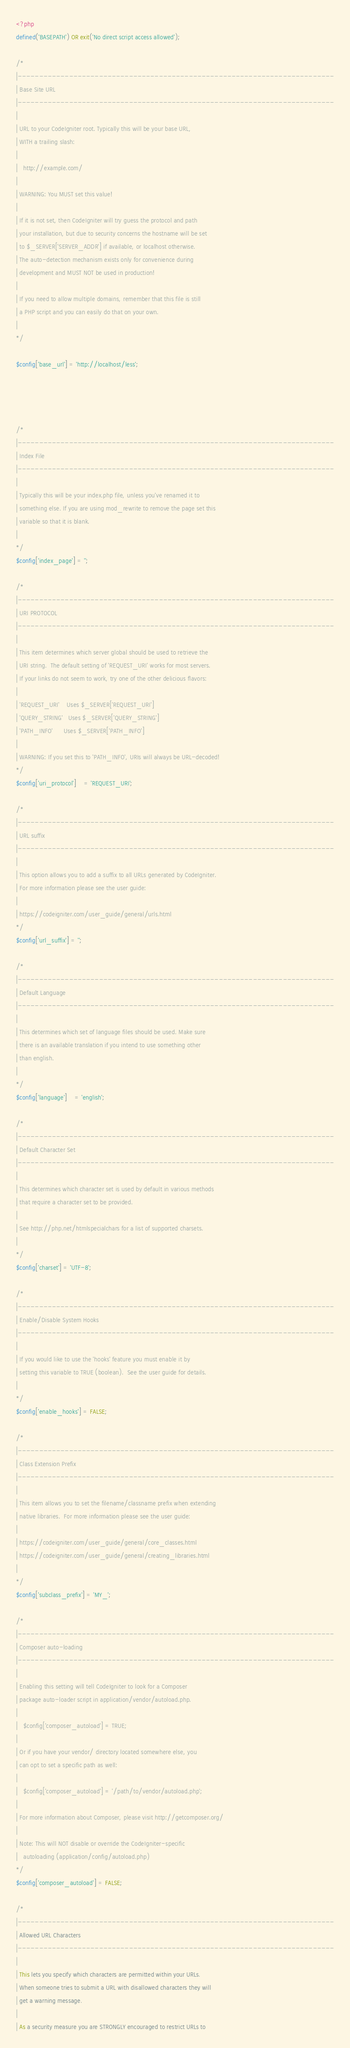Convert code to text. <code><loc_0><loc_0><loc_500><loc_500><_PHP_><?php
defined('BASEPATH') OR exit('No direct script access allowed');

/*
|--------------------------------------------------------------------------
| Base Site URL
|--------------------------------------------------------------------------
|
| URL to your CodeIgniter root. Typically this will be your base URL,
| WITH a trailing slash:
|
|	http://example.com/
|
| WARNING: You MUST set this value!
|
| If it is not set, then CodeIgniter will try guess the protocol and path
| your installation, but due to security concerns the hostname will be set
| to $_SERVER['SERVER_ADDR'] if available, or localhost otherwise.
| The auto-detection mechanism exists only for convenience during
| development and MUST NOT be used in production!
|
| If you need to allow multiple domains, remember that this file is still
| a PHP script and you can easily do that on your own.
|
*/

$config['base_url'] = 'http://localhost/less';




/*
|--------------------------------------------------------------------------
| Index File
|--------------------------------------------------------------------------
|
| Typically this will be your index.php file, unless you've renamed it to
| something else. If you are using mod_rewrite to remove the page set this
| variable so that it is blank.
|
*/
$config['index_page'] = '';

/*
|--------------------------------------------------------------------------
| URI PROTOCOL
|--------------------------------------------------------------------------
|
| This item determines which server global should be used to retrieve the
| URI string.  The default setting of 'REQUEST_URI' works for most servers.
| If your links do not seem to work, try one of the other delicious flavors:
|
| 'REQUEST_URI'    Uses $_SERVER['REQUEST_URI']
| 'QUERY_STRING'   Uses $_SERVER['QUERY_STRING']
| 'PATH_INFO'      Uses $_SERVER['PATH_INFO']
|
| WARNING: If you set this to 'PATH_INFO', URIs will always be URL-decoded!
*/
$config['uri_protocol']	= 'REQUEST_URI';

/*
|--------------------------------------------------------------------------
| URL suffix
|--------------------------------------------------------------------------
|
| This option allows you to add a suffix to all URLs generated by CodeIgniter.
| For more information please see the user guide:
|
| https://codeigniter.com/user_guide/general/urls.html
*/
$config['url_suffix'] = '';

/*
|--------------------------------------------------------------------------
| Default Language
|--------------------------------------------------------------------------
|
| This determines which set of language files should be used. Make sure
| there is an available translation if you intend to use something other
| than english.
|
*/
$config['language']	= 'english';

/*
|--------------------------------------------------------------------------
| Default Character Set
|--------------------------------------------------------------------------
|
| This determines which character set is used by default in various methods
| that require a character set to be provided.
|
| See http://php.net/htmlspecialchars for a list of supported charsets.
|
*/
$config['charset'] = 'UTF-8';

/*
|--------------------------------------------------------------------------
| Enable/Disable System Hooks
|--------------------------------------------------------------------------
|
| If you would like to use the 'hooks' feature you must enable it by
| setting this variable to TRUE (boolean).  See the user guide for details.
|
*/
$config['enable_hooks'] = FALSE;

/*
|--------------------------------------------------------------------------
| Class Extension Prefix
|--------------------------------------------------------------------------
|
| This item allows you to set the filename/classname prefix when extending
| native libraries.  For more information please see the user guide:
|
| https://codeigniter.com/user_guide/general/core_classes.html
| https://codeigniter.com/user_guide/general/creating_libraries.html
|
*/
$config['subclass_prefix'] = 'MY_';

/*
|--------------------------------------------------------------------------
| Composer auto-loading
|--------------------------------------------------------------------------
|
| Enabling this setting will tell CodeIgniter to look for a Composer
| package auto-loader script in application/vendor/autoload.php.
|
|	$config['composer_autoload'] = TRUE;
|
| Or if you have your vendor/ directory located somewhere else, you
| can opt to set a specific path as well:
|
|	$config['composer_autoload'] = '/path/to/vendor/autoload.php';
|
| For more information about Composer, please visit http://getcomposer.org/
|
| Note: This will NOT disable or override the CodeIgniter-specific
|	autoloading (application/config/autoload.php)
*/
$config['composer_autoload'] = FALSE;

/*
|--------------------------------------------------------------------------
| Allowed URL Characters
|--------------------------------------------------------------------------
|
| This lets you specify which characters are permitted within your URLs.
| When someone tries to submit a URL with disallowed characters they will
| get a warning message.
|
| As a security measure you are STRONGLY encouraged to restrict URLs to</code> 